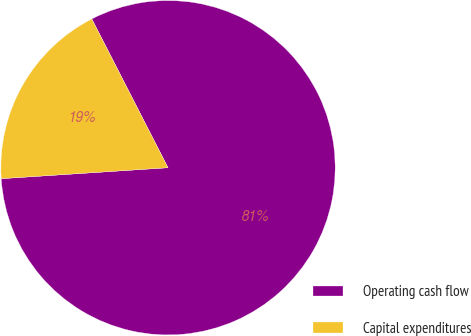Convert chart to OTSL. <chart><loc_0><loc_0><loc_500><loc_500><pie_chart><fcel>Operating cash flow<fcel>Capital expenditures<nl><fcel>81.49%<fcel>18.51%<nl></chart> 